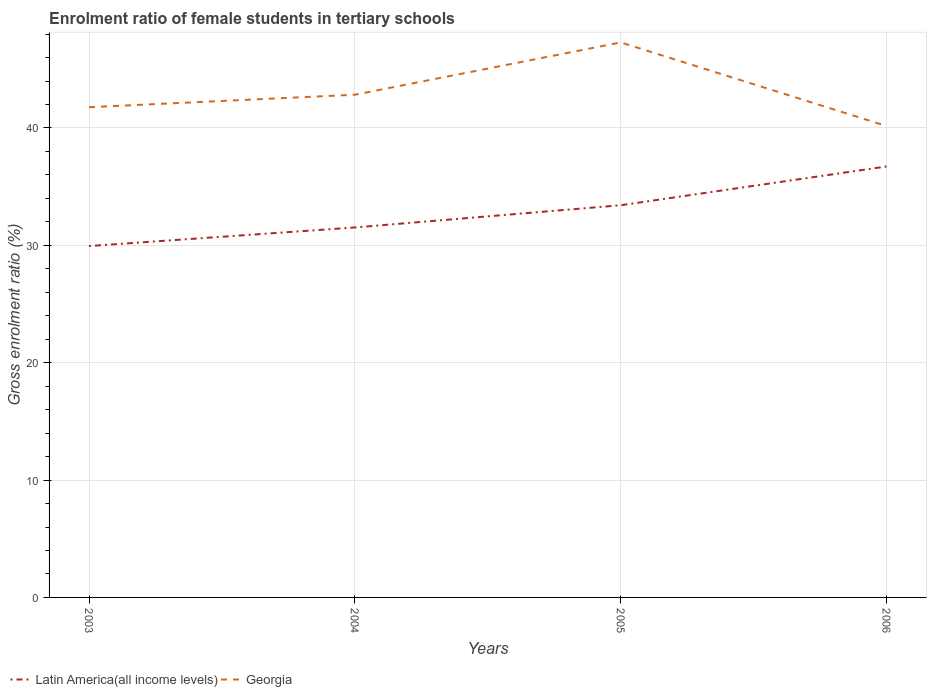How many different coloured lines are there?
Your answer should be compact. 2. Does the line corresponding to Georgia intersect with the line corresponding to Latin America(all income levels)?
Your response must be concise. No. Is the number of lines equal to the number of legend labels?
Your answer should be compact. Yes. Across all years, what is the maximum enrolment ratio of female students in tertiary schools in Georgia?
Give a very brief answer. 40.16. In which year was the enrolment ratio of female students in tertiary schools in Georgia maximum?
Your response must be concise. 2006. What is the total enrolment ratio of female students in tertiary schools in Latin America(all income levels) in the graph?
Ensure brevity in your answer.  -6.78. What is the difference between the highest and the second highest enrolment ratio of female students in tertiary schools in Georgia?
Offer a very short reply. 7.12. Is the enrolment ratio of female students in tertiary schools in Latin America(all income levels) strictly greater than the enrolment ratio of female students in tertiary schools in Georgia over the years?
Keep it short and to the point. Yes. How many lines are there?
Offer a terse response. 2. How many years are there in the graph?
Your answer should be compact. 4. What is the difference between two consecutive major ticks on the Y-axis?
Ensure brevity in your answer.  10. Where does the legend appear in the graph?
Provide a short and direct response. Bottom left. How many legend labels are there?
Your response must be concise. 2. What is the title of the graph?
Offer a terse response. Enrolment ratio of female students in tertiary schools. Does "Moldova" appear as one of the legend labels in the graph?
Offer a terse response. No. What is the label or title of the X-axis?
Make the answer very short. Years. What is the label or title of the Y-axis?
Keep it short and to the point. Gross enrolment ratio (%). What is the Gross enrolment ratio (%) of Latin America(all income levels) in 2003?
Provide a short and direct response. 29.94. What is the Gross enrolment ratio (%) in Georgia in 2003?
Give a very brief answer. 41.77. What is the Gross enrolment ratio (%) in Latin America(all income levels) in 2004?
Your response must be concise. 31.52. What is the Gross enrolment ratio (%) in Georgia in 2004?
Provide a succinct answer. 42.83. What is the Gross enrolment ratio (%) of Latin America(all income levels) in 2005?
Provide a short and direct response. 33.42. What is the Gross enrolment ratio (%) of Georgia in 2005?
Offer a very short reply. 47.29. What is the Gross enrolment ratio (%) in Latin America(all income levels) in 2006?
Your response must be concise. 36.72. What is the Gross enrolment ratio (%) of Georgia in 2006?
Give a very brief answer. 40.16. Across all years, what is the maximum Gross enrolment ratio (%) of Latin America(all income levels)?
Give a very brief answer. 36.72. Across all years, what is the maximum Gross enrolment ratio (%) in Georgia?
Your answer should be very brief. 47.29. Across all years, what is the minimum Gross enrolment ratio (%) of Latin America(all income levels)?
Offer a very short reply. 29.94. Across all years, what is the minimum Gross enrolment ratio (%) of Georgia?
Offer a terse response. 40.16. What is the total Gross enrolment ratio (%) of Latin America(all income levels) in the graph?
Offer a terse response. 131.6. What is the total Gross enrolment ratio (%) of Georgia in the graph?
Ensure brevity in your answer.  172.05. What is the difference between the Gross enrolment ratio (%) of Latin America(all income levels) in 2003 and that in 2004?
Make the answer very short. -1.58. What is the difference between the Gross enrolment ratio (%) in Georgia in 2003 and that in 2004?
Your response must be concise. -1.07. What is the difference between the Gross enrolment ratio (%) of Latin America(all income levels) in 2003 and that in 2005?
Offer a very short reply. -3.48. What is the difference between the Gross enrolment ratio (%) in Georgia in 2003 and that in 2005?
Offer a terse response. -5.52. What is the difference between the Gross enrolment ratio (%) in Latin America(all income levels) in 2003 and that in 2006?
Your response must be concise. -6.78. What is the difference between the Gross enrolment ratio (%) in Georgia in 2003 and that in 2006?
Provide a short and direct response. 1.6. What is the difference between the Gross enrolment ratio (%) of Latin America(all income levels) in 2004 and that in 2005?
Give a very brief answer. -1.89. What is the difference between the Gross enrolment ratio (%) of Georgia in 2004 and that in 2005?
Offer a terse response. -4.45. What is the difference between the Gross enrolment ratio (%) in Latin America(all income levels) in 2004 and that in 2006?
Offer a very short reply. -5.2. What is the difference between the Gross enrolment ratio (%) of Georgia in 2004 and that in 2006?
Make the answer very short. 2.67. What is the difference between the Gross enrolment ratio (%) of Latin America(all income levels) in 2005 and that in 2006?
Offer a terse response. -3.3. What is the difference between the Gross enrolment ratio (%) in Georgia in 2005 and that in 2006?
Your response must be concise. 7.12. What is the difference between the Gross enrolment ratio (%) in Latin America(all income levels) in 2003 and the Gross enrolment ratio (%) in Georgia in 2004?
Provide a short and direct response. -12.89. What is the difference between the Gross enrolment ratio (%) in Latin America(all income levels) in 2003 and the Gross enrolment ratio (%) in Georgia in 2005?
Make the answer very short. -17.35. What is the difference between the Gross enrolment ratio (%) of Latin America(all income levels) in 2003 and the Gross enrolment ratio (%) of Georgia in 2006?
Offer a very short reply. -10.22. What is the difference between the Gross enrolment ratio (%) of Latin America(all income levels) in 2004 and the Gross enrolment ratio (%) of Georgia in 2005?
Your answer should be very brief. -15.76. What is the difference between the Gross enrolment ratio (%) in Latin America(all income levels) in 2004 and the Gross enrolment ratio (%) in Georgia in 2006?
Your answer should be compact. -8.64. What is the difference between the Gross enrolment ratio (%) of Latin America(all income levels) in 2005 and the Gross enrolment ratio (%) of Georgia in 2006?
Ensure brevity in your answer.  -6.75. What is the average Gross enrolment ratio (%) in Latin America(all income levels) per year?
Your answer should be compact. 32.9. What is the average Gross enrolment ratio (%) of Georgia per year?
Your answer should be compact. 43.01. In the year 2003, what is the difference between the Gross enrolment ratio (%) of Latin America(all income levels) and Gross enrolment ratio (%) of Georgia?
Offer a terse response. -11.83. In the year 2004, what is the difference between the Gross enrolment ratio (%) of Latin America(all income levels) and Gross enrolment ratio (%) of Georgia?
Provide a succinct answer. -11.31. In the year 2005, what is the difference between the Gross enrolment ratio (%) of Latin America(all income levels) and Gross enrolment ratio (%) of Georgia?
Your response must be concise. -13.87. In the year 2006, what is the difference between the Gross enrolment ratio (%) of Latin America(all income levels) and Gross enrolment ratio (%) of Georgia?
Your answer should be very brief. -3.44. What is the ratio of the Gross enrolment ratio (%) of Latin America(all income levels) in 2003 to that in 2004?
Keep it short and to the point. 0.95. What is the ratio of the Gross enrolment ratio (%) in Georgia in 2003 to that in 2004?
Ensure brevity in your answer.  0.98. What is the ratio of the Gross enrolment ratio (%) of Latin America(all income levels) in 2003 to that in 2005?
Your answer should be very brief. 0.9. What is the ratio of the Gross enrolment ratio (%) in Georgia in 2003 to that in 2005?
Your answer should be very brief. 0.88. What is the ratio of the Gross enrolment ratio (%) of Latin America(all income levels) in 2003 to that in 2006?
Your answer should be very brief. 0.82. What is the ratio of the Gross enrolment ratio (%) of Georgia in 2003 to that in 2006?
Give a very brief answer. 1.04. What is the ratio of the Gross enrolment ratio (%) in Latin America(all income levels) in 2004 to that in 2005?
Provide a short and direct response. 0.94. What is the ratio of the Gross enrolment ratio (%) in Georgia in 2004 to that in 2005?
Your answer should be compact. 0.91. What is the ratio of the Gross enrolment ratio (%) in Latin America(all income levels) in 2004 to that in 2006?
Keep it short and to the point. 0.86. What is the ratio of the Gross enrolment ratio (%) in Georgia in 2004 to that in 2006?
Your answer should be compact. 1.07. What is the ratio of the Gross enrolment ratio (%) of Latin America(all income levels) in 2005 to that in 2006?
Keep it short and to the point. 0.91. What is the ratio of the Gross enrolment ratio (%) of Georgia in 2005 to that in 2006?
Ensure brevity in your answer.  1.18. What is the difference between the highest and the second highest Gross enrolment ratio (%) of Latin America(all income levels)?
Provide a succinct answer. 3.3. What is the difference between the highest and the second highest Gross enrolment ratio (%) of Georgia?
Your answer should be very brief. 4.45. What is the difference between the highest and the lowest Gross enrolment ratio (%) of Latin America(all income levels)?
Provide a succinct answer. 6.78. What is the difference between the highest and the lowest Gross enrolment ratio (%) in Georgia?
Keep it short and to the point. 7.12. 